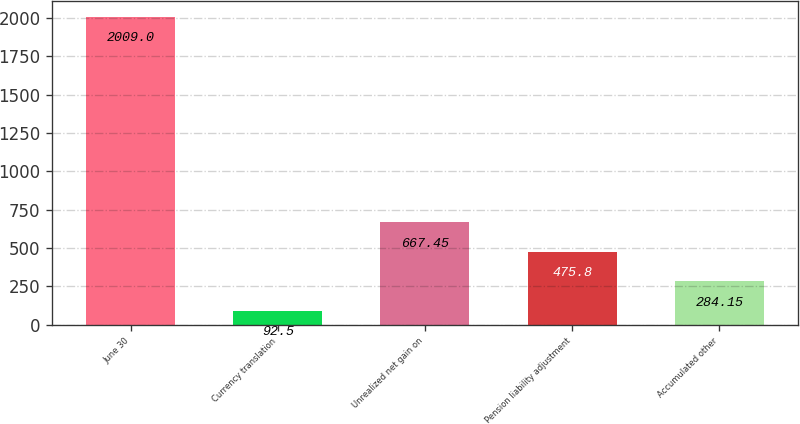<chart> <loc_0><loc_0><loc_500><loc_500><bar_chart><fcel>June 30<fcel>Currency translation<fcel>Unrealized net gain on<fcel>Pension liability adjustment<fcel>Accumulated other<nl><fcel>2009<fcel>92.5<fcel>667.45<fcel>475.8<fcel>284.15<nl></chart> 